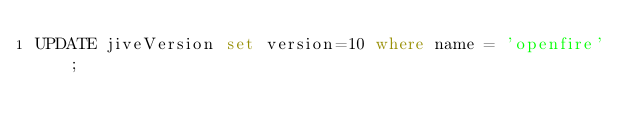Convert code to text. <code><loc_0><loc_0><loc_500><loc_500><_SQL_>UPDATE jiveVersion set version=10 where name = 'openfire';
</code> 